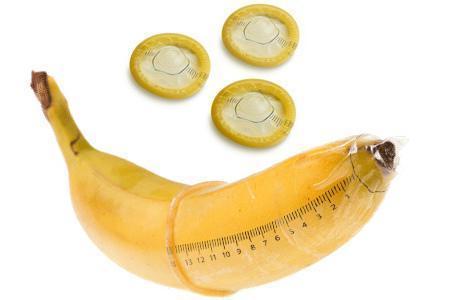How many bananas are visible?
Give a very brief answer. 1. 